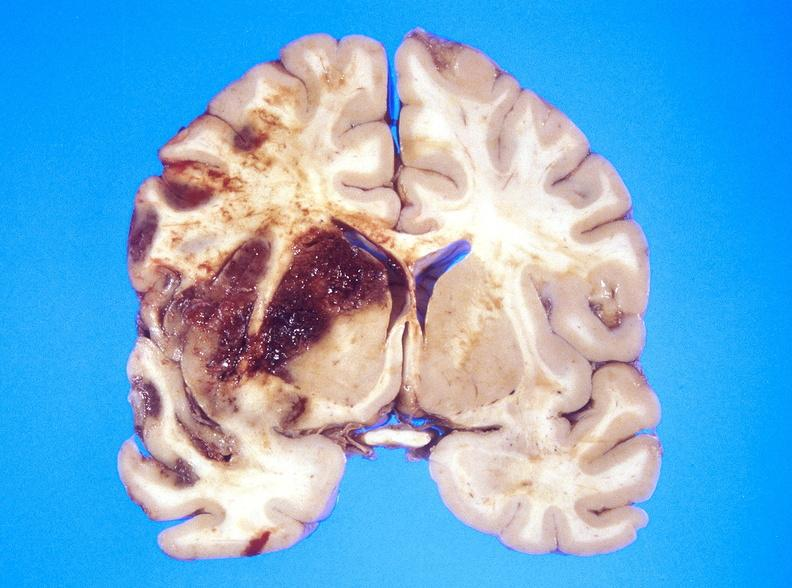s nervous present?
Answer the question using a single word or phrase. Yes 